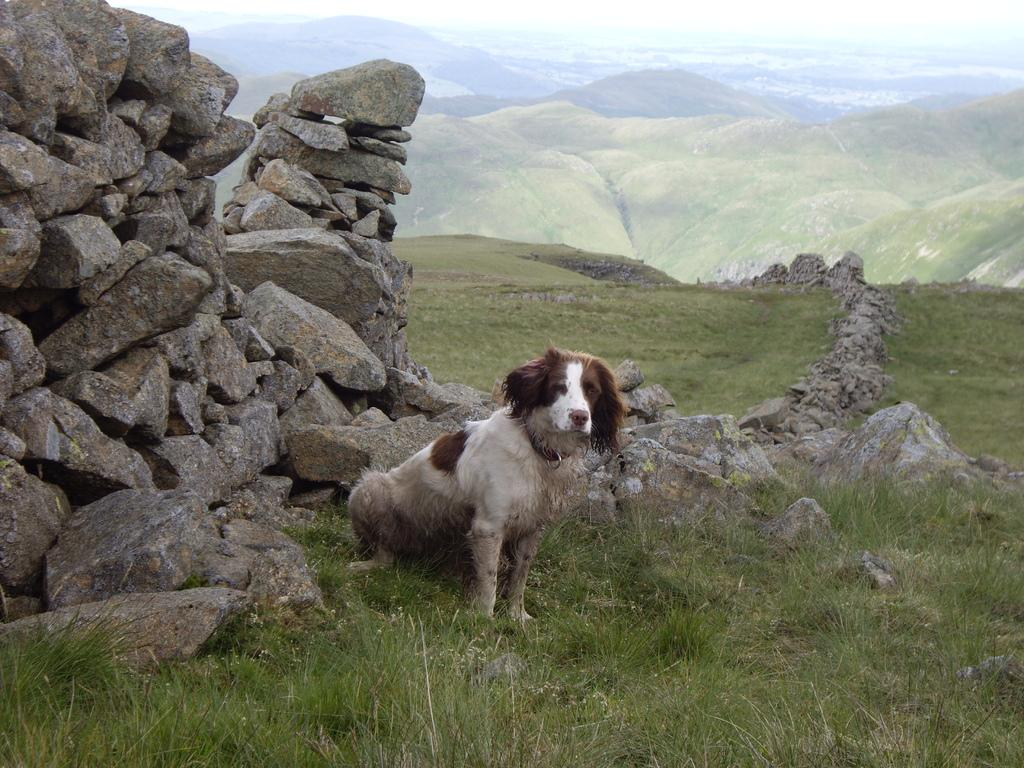What type of animal is in the image? There is a dog in the image. Can you describe the appearance of the dog? The dog is brown and white in color. What can be seen on the ground in the image? There are many rocks in the image. What is visible in the distance in the image? There are mountains visible in the background of the image, and the sky is also visible. What flavor of ice cream is the dog holding in the image? There is no ice cream present in the image, and the dog is not holding anything. 